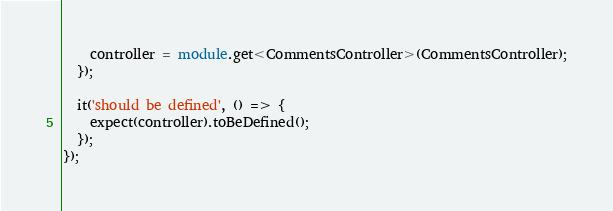<code> <loc_0><loc_0><loc_500><loc_500><_TypeScript_>    controller = module.get<CommentsController>(CommentsController);
  });

  it('should be defined', () => {
    expect(controller).toBeDefined();
  });
});
</code> 